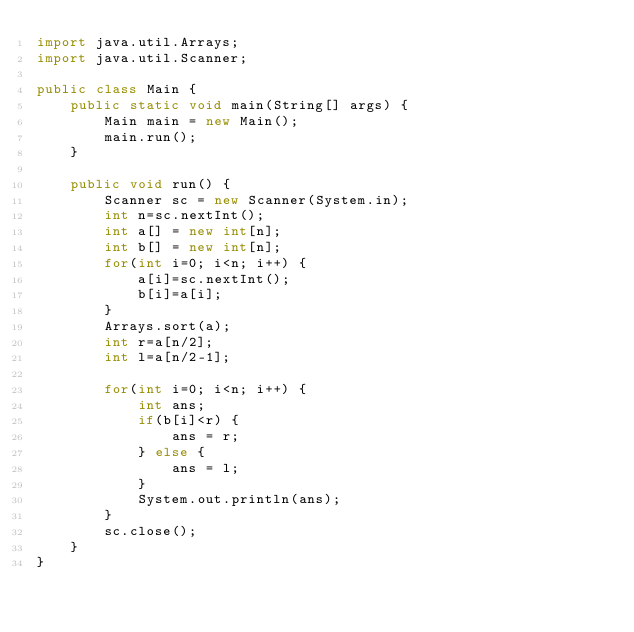<code> <loc_0><loc_0><loc_500><loc_500><_Java_>import java.util.Arrays;
import java.util.Scanner;

public class Main {
	public static void main(String[] args) {
		Main main = new Main();
		main.run();
	}

	public void run() {
		Scanner sc = new Scanner(System.in);
		int n=sc.nextInt();
		int a[] = new int[n];
		int b[] = new int[n];
		for(int i=0; i<n; i++) {
			a[i]=sc.nextInt();
			b[i]=a[i];
		}
		Arrays.sort(a);
		int r=a[n/2];
		int l=a[n/2-1];

		for(int i=0; i<n; i++) {
			int ans;
			if(b[i]<r) {
				ans = r;
			} else {
				ans = l;
			}
			System.out.println(ans);
		}
		sc.close();
	}
}
</code> 